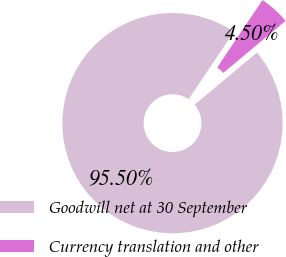<chart> <loc_0><loc_0><loc_500><loc_500><pie_chart><fcel>Goodwill net at 30 September<fcel>Currency translation and other<nl><fcel>95.5%<fcel>4.5%<nl></chart> 